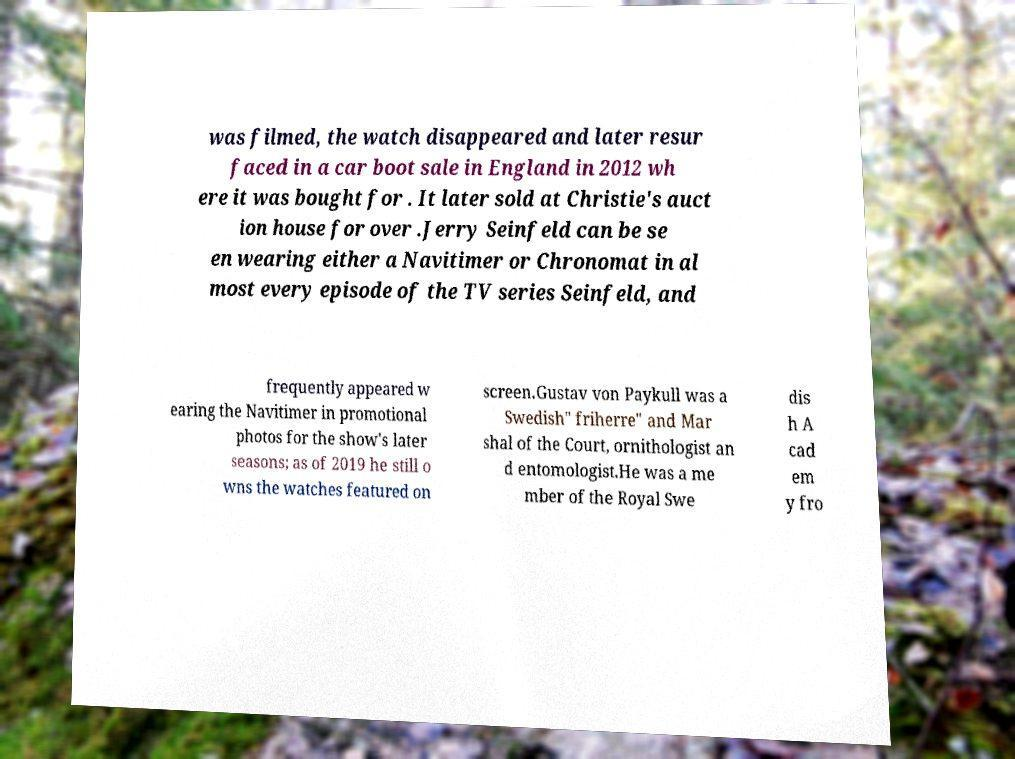Could you extract and type out the text from this image? was filmed, the watch disappeared and later resur faced in a car boot sale in England in 2012 wh ere it was bought for . It later sold at Christie's auct ion house for over .Jerry Seinfeld can be se en wearing either a Navitimer or Chronomat in al most every episode of the TV series Seinfeld, and frequently appeared w earing the Navitimer in promotional photos for the show's later seasons; as of 2019 he still o wns the watches featured on screen.Gustav von Paykull was a Swedish" friherre" and Mar shal of the Court, ornithologist an d entomologist.He was a me mber of the Royal Swe dis h A cad em y fro 